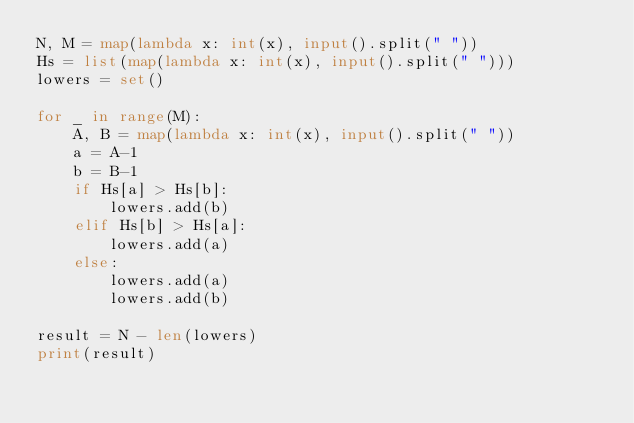<code> <loc_0><loc_0><loc_500><loc_500><_Python_>N, M = map(lambda x: int(x), input().split(" "))
Hs = list(map(lambda x: int(x), input().split(" ")))
lowers = set()

for _ in range(M):
    A, B = map(lambda x: int(x), input().split(" "))
    a = A-1
    b = B-1
    if Hs[a] > Hs[b]:
        lowers.add(b)
    elif Hs[b] > Hs[a]:
        lowers.add(a)
    else:
        lowers.add(a)
        lowers.add(b)

result = N - len(lowers)
print(result)
</code> 